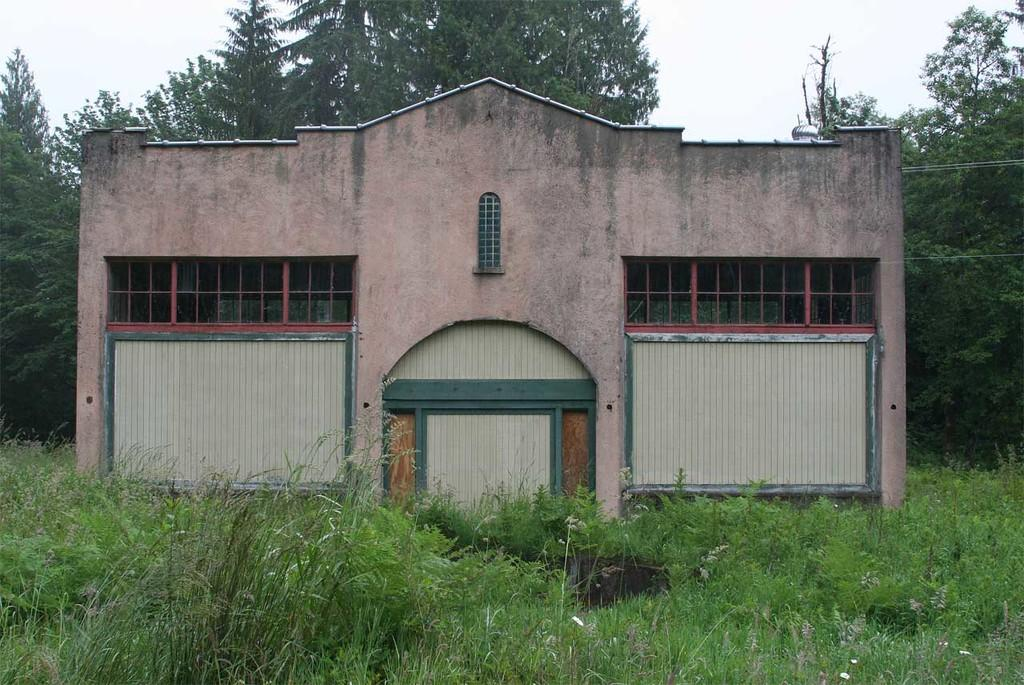What is the main structure in the center of the image? There is a building in the center of the image. What type of vegetation is present at the bottom of the image? Grass and plants are present at the bottom of the image. What can be seen in the background of the image? There are trees and the sky visible in the background of the image. Where is the shop selling yarn located in the image? There is no shop selling yarn present in the image. What type of doll can be seen playing with the yarn in the image? There is no doll or yarn present in the image. 